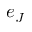Convert formula to latex. <formula><loc_0><loc_0><loc_500><loc_500>e _ { J }</formula> 